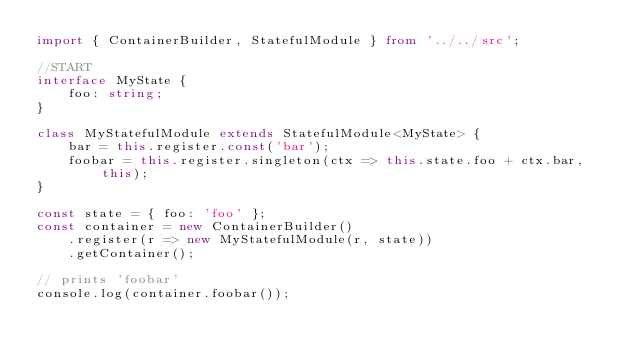Convert code to text. <code><loc_0><loc_0><loc_500><loc_500><_TypeScript_>import { ContainerBuilder, StatefulModule } from '../../src';

//START
interface MyState {
    foo: string;
}

class MyStatefulModule extends StatefulModule<MyState> {
    bar = this.register.const('bar');
    foobar = this.register.singleton(ctx => this.state.foo + ctx.bar, this);
}

const state = { foo: 'foo' };
const container = new ContainerBuilder()
    .register(r => new MyStatefulModule(r, state))
    .getContainer();

// prints 'foobar'
console.log(container.foobar());

</code> 